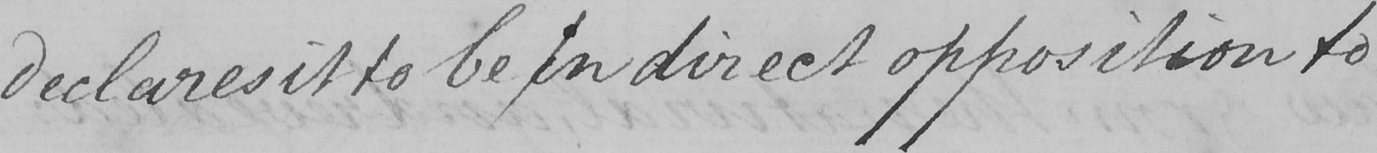What does this handwritten line say? declares it to be in direct opposition to 